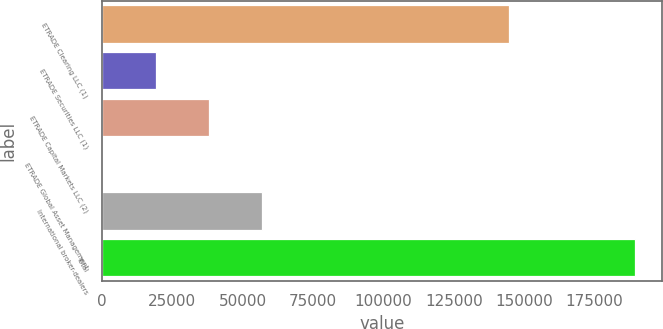Convert chart. <chart><loc_0><loc_0><loc_500><loc_500><bar_chart><fcel>ETRADE Clearing LLC (1)<fcel>ETRADE Securities LLC (1)<fcel>ETRADE Capital Markets LLC (2)<fcel>ETRADE Global Asset Management<fcel>International broker-dealers<fcel>Total<nl><fcel>144471<fcel>19087.1<fcel>38019.2<fcel>155<fcel>56951.3<fcel>189476<nl></chart> 